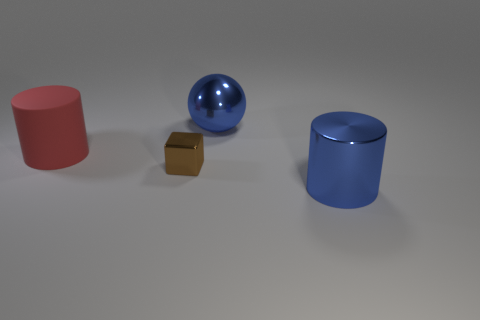How do the objects in the image compare in terms of their reflective properties? The objects demonstrate a range of reflective qualities. The blue sphere and the cylindrical object both have a high-gloss finish that reflect light strongly, whereas the small brown block has a muted, matte surface causing it to reflect less light and appear less shiny.  Could you describe the lighting in the scene? Certainly. The scene is lit from above, casting soft shadows beneath each object. The light source appears to be diffused, creating subtle gradations of light and shadow on the objects, giving the image a calm and balanced atmosphere. 